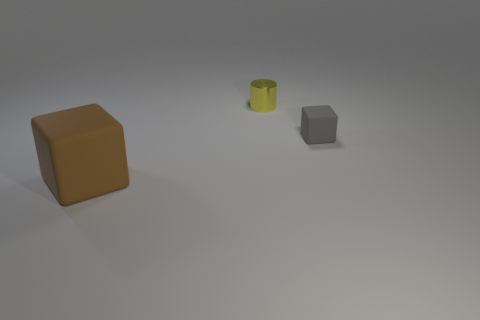Is there any other thing that has the same material as the tiny yellow cylinder?
Keep it short and to the point. No. What size is the brown rubber thing that is the same shape as the small gray object?
Keep it short and to the point. Large. Are there any yellow shiny balls?
Your answer should be compact. No. What number of things are rubber cubes left of the tiny yellow cylinder or yellow objects?
Your answer should be compact. 2. There is a cylinder that is the same size as the gray matte thing; what is it made of?
Offer a very short reply. Metal. There is a block in front of the matte block on the right side of the big brown object; what is its color?
Give a very brief answer. Brown. There is a large object; how many matte blocks are right of it?
Give a very brief answer. 1. The tiny rubber block is what color?
Give a very brief answer. Gray. How many tiny things are cyan cylinders or brown rubber objects?
Your answer should be very brief. 0. What number of other objects are there of the same color as the big thing?
Keep it short and to the point. 0. 